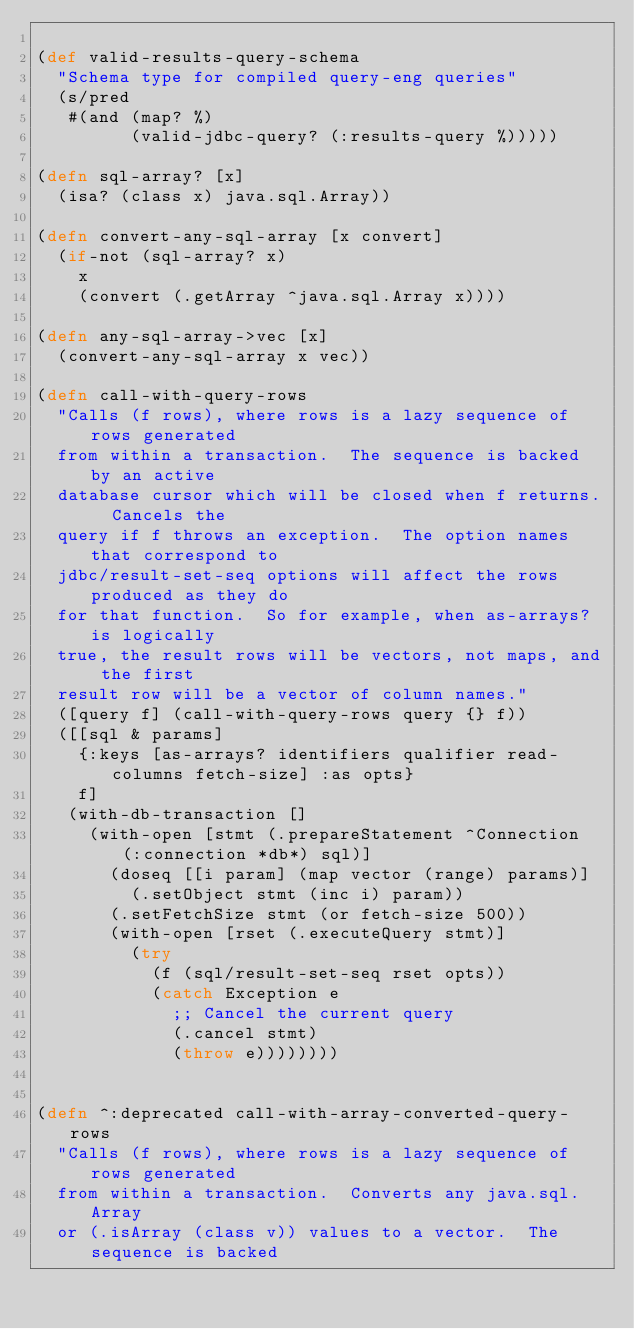<code> <loc_0><loc_0><loc_500><loc_500><_Clojure_>
(def valid-results-query-schema
  "Schema type for compiled query-eng queries"
  (s/pred
   #(and (map? %)
         (valid-jdbc-query? (:results-query %)))))

(defn sql-array? [x]
  (isa? (class x) java.sql.Array))

(defn convert-any-sql-array [x convert]
  (if-not (sql-array? x)
    x
    (convert (.getArray ^java.sql.Array x))))

(defn any-sql-array->vec [x]
  (convert-any-sql-array x vec))

(defn call-with-query-rows
  "Calls (f rows), where rows is a lazy sequence of rows generated
  from within a transaction.  The sequence is backed by an active
  database cursor which will be closed when f returns.  Cancels the
  query if f throws an exception.  The option names that correspond to
  jdbc/result-set-seq options will affect the rows produced as they do
  for that function.  So for example, when as-arrays? is logically
  true, the result rows will be vectors, not maps, and the first
  result row will be a vector of column names."
  ([query f] (call-with-query-rows query {} f))
  ([[sql & params]
    {:keys [as-arrays? identifiers qualifier read-columns fetch-size] :as opts}
    f]
   (with-db-transaction []
     (with-open [stmt (.prepareStatement ^Connection (:connection *db*) sql)]
       (doseq [[i param] (map vector (range) params)]
         (.setObject stmt (inc i) param))
       (.setFetchSize stmt (or fetch-size 500))
       (with-open [rset (.executeQuery stmt)]
         (try
           (f (sql/result-set-seq rset opts))
           (catch Exception e
             ;; Cancel the current query
             (.cancel stmt)
             (throw e))))))))


(defn ^:deprecated call-with-array-converted-query-rows
  "Calls (f rows), where rows is a lazy sequence of rows generated
  from within a transaction.  Converts any java.sql.Array
  or (.isArray (class v)) values to a vector.  The sequence is backed</code> 